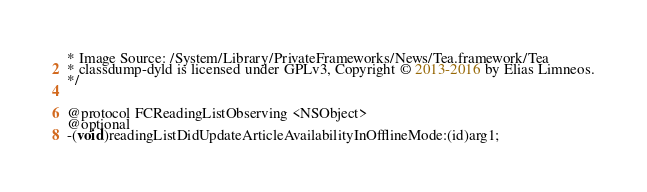Convert code to text. <code><loc_0><loc_0><loc_500><loc_500><_C_>* Image Source: /System/Library/PrivateFrameworks/News/Tea.framework/Tea
* classdump-dyld is licensed under GPLv3, Copyright © 2013-2016 by Elias Limneos.
*/


@protocol FCReadingListObserving <NSObject>
@optional
-(void)readingListDidUpdateArticleAvailabilityInOfflineMode:(id)arg1;</code> 